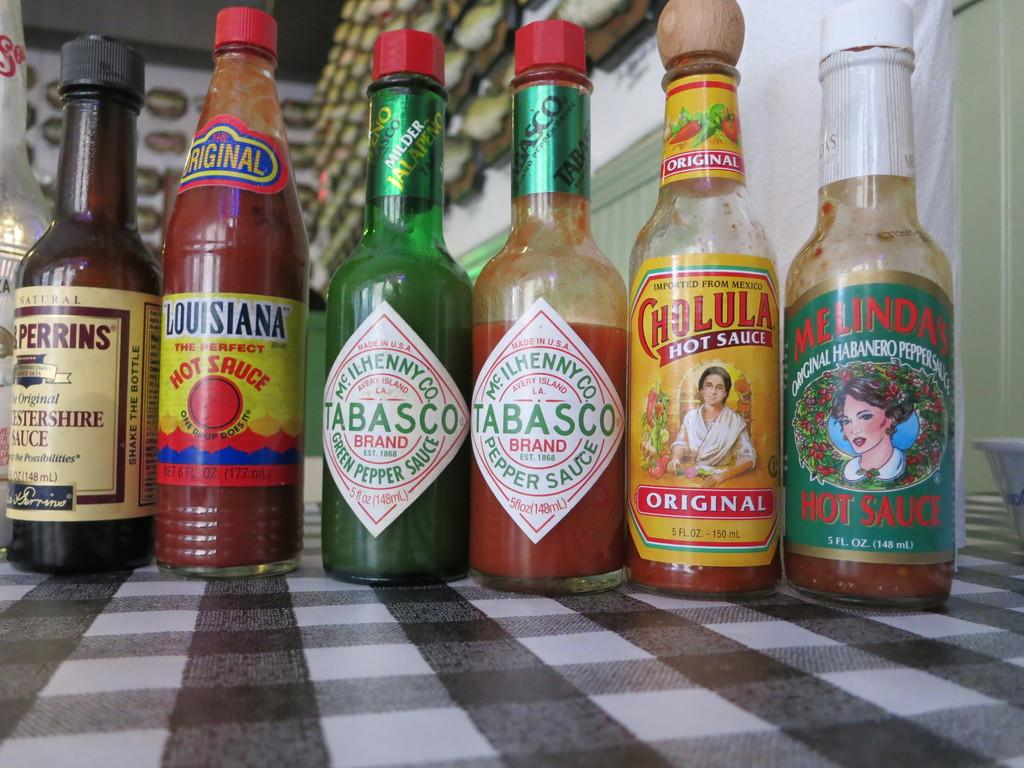<image>
Render a clear and concise summary of the photo. Louisana Hot Sauce, Tabasco hot sauce, Cholula Hot Sauce and Worchesterine sauce on a table. 